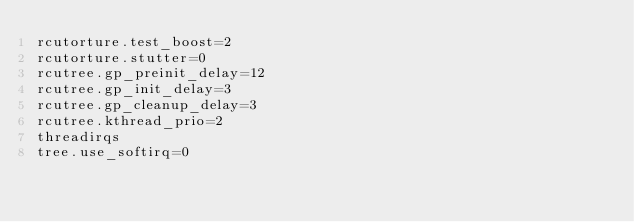<code> <loc_0><loc_0><loc_500><loc_500><_Clojure_>rcutorture.test_boost=2
rcutorture.stutter=0
rcutree.gp_preinit_delay=12
rcutree.gp_init_delay=3
rcutree.gp_cleanup_delay=3
rcutree.kthread_prio=2
threadirqs
tree.use_softirq=0
</code> 